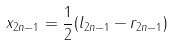Convert formula to latex. <formula><loc_0><loc_0><loc_500><loc_500>x _ { 2 n - 1 } = \frac { 1 } { 2 } ( l _ { 2 n - 1 } - r _ { 2 n - 1 } )</formula> 